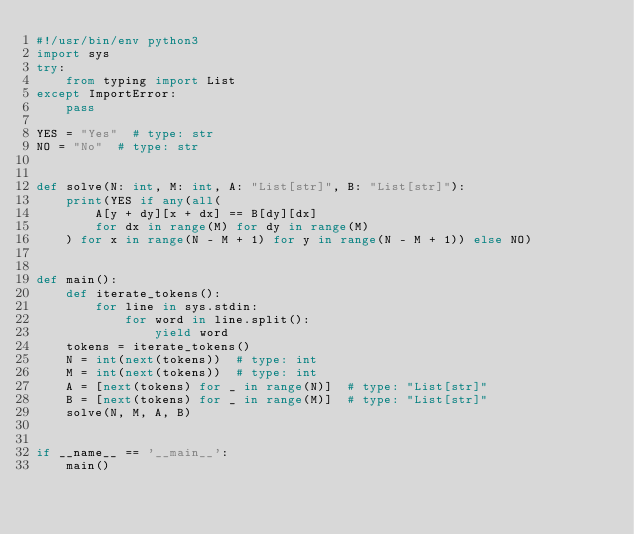<code> <loc_0><loc_0><loc_500><loc_500><_Python_>#!/usr/bin/env python3
import sys
try:
    from typing import List
except ImportError:
    pass

YES = "Yes"  # type: str
NO = "No"  # type: str


def solve(N: int, M: int, A: "List[str]", B: "List[str]"):
    print(YES if any(all(
        A[y + dy][x + dx] == B[dy][dx]
        for dx in range(M) for dy in range(M)
    ) for x in range(N - M + 1) for y in range(N - M + 1)) else NO)


def main():
    def iterate_tokens():
        for line in sys.stdin:
            for word in line.split():
                yield word
    tokens = iterate_tokens()
    N = int(next(tokens))  # type: int
    M = int(next(tokens))  # type: int
    A = [next(tokens) for _ in range(N)]  # type: "List[str]"
    B = [next(tokens) for _ in range(M)]  # type: "List[str]"
    solve(N, M, A, B)


if __name__ == '__main__':
    main()
</code> 